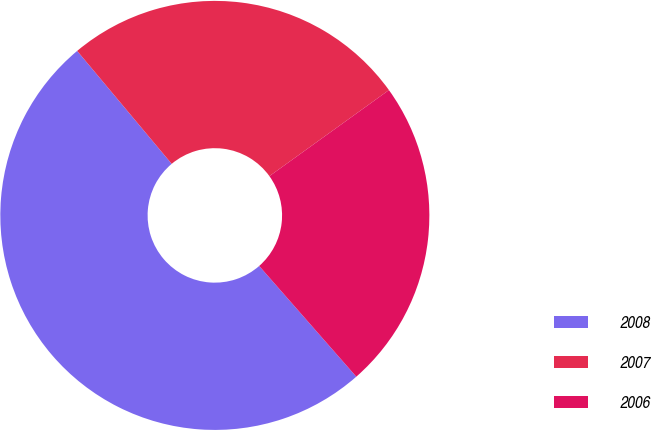<chart> <loc_0><loc_0><loc_500><loc_500><pie_chart><fcel>2008<fcel>2007<fcel>2006<nl><fcel>50.37%<fcel>26.16%<fcel>23.47%<nl></chart> 